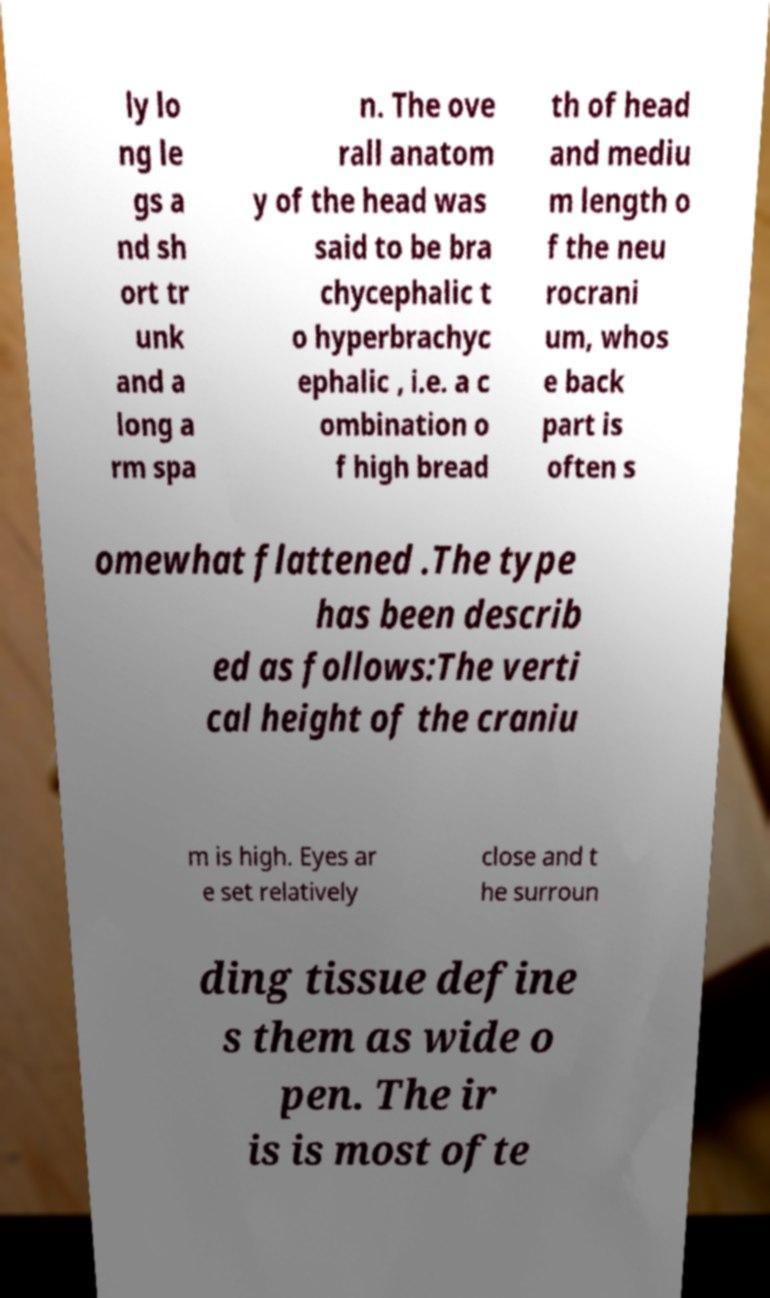Please identify and transcribe the text found in this image. ly lo ng le gs a nd sh ort tr unk and a long a rm spa n. The ove rall anatom y of the head was said to be bra chycephalic t o hyperbrachyc ephalic , i.e. a c ombination o f high bread th of head and mediu m length o f the neu rocrani um, whos e back part is often s omewhat flattened .The type has been describ ed as follows:The verti cal height of the craniu m is high. Eyes ar e set relatively close and t he surroun ding tissue define s them as wide o pen. The ir is is most ofte 